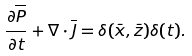Convert formula to latex. <formula><loc_0><loc_0><loc_500><loc_500>\frac { \partial \overline { P } } { \partial t } + \nabla \cdot { \overline { J } } = \delta ( \bar { x } , \bar { z } ) \delta ( t ) .</formula> 